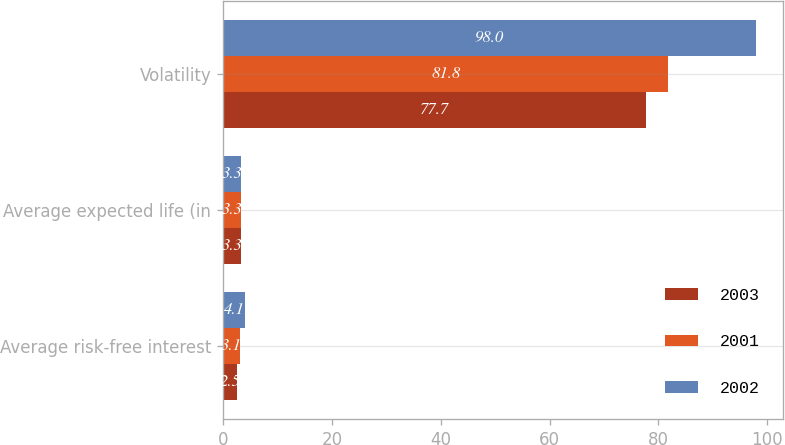Convert chart. <chart><loc_0><loc_0><loc_500><loc_500><stacked_bar_chart><ecel><fcel>Average risk-free interest<fcel>Average expected life (in<fcel>Volatility<nl><fcel>2003<fcel>2.5<fcel>3.3<fcel>77.7<nl><fcel>2001<fcel>3.1<fcel>3.3<fcel>81.8<nl><fcel>2002<fcel>4.1<fcel>3.3<fcel>98<nl></chart> 